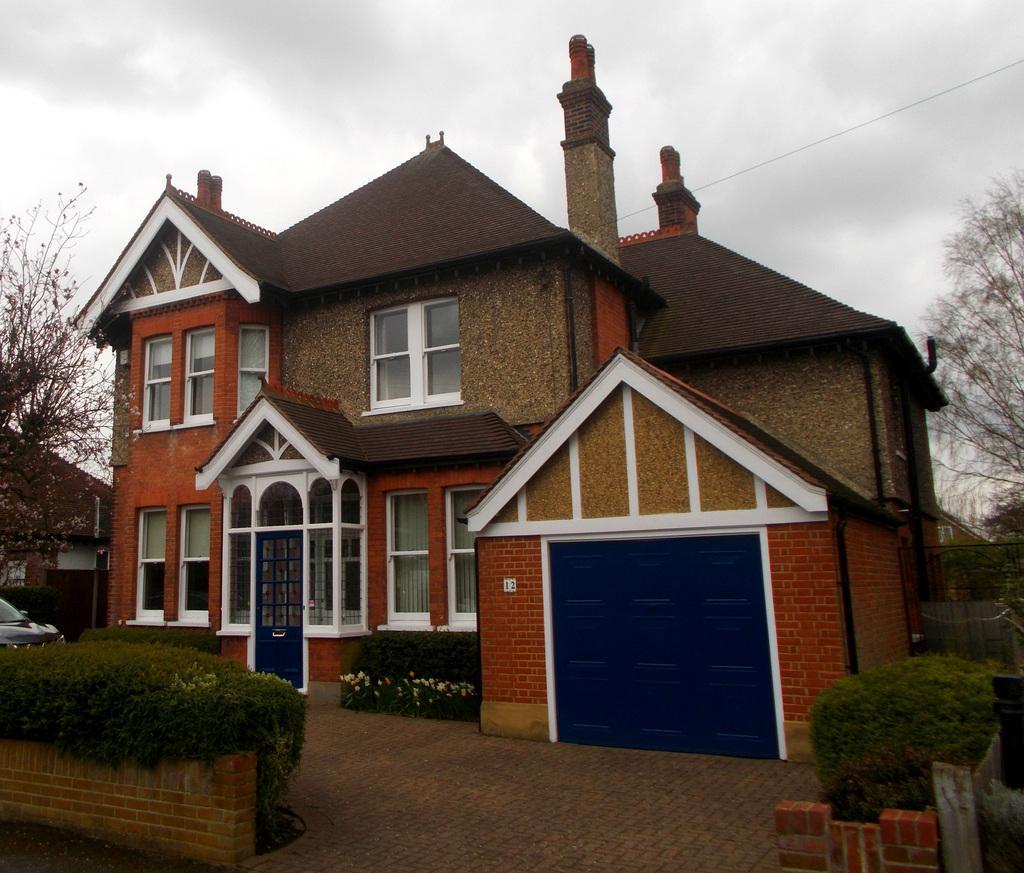Could you give a brief overview of what you see in this image? In this image in the center there is one house, and in the background there are some houses, trees. And on the left side there is one car, and at the bottom of the image there is one car and plants, flowers and a walkway. And at the top there is sky and some wire. 